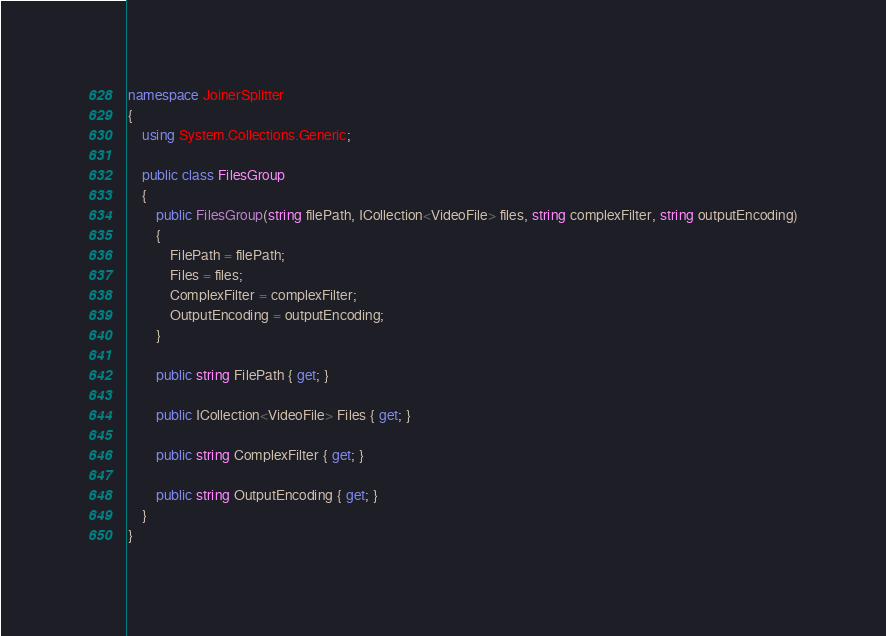<code> <loc_0><loc_0><loc_500><loc_500><_C#_>namespace JoinerSplitter
{
    using System.Collections.Generic;

    public class FilesGroup
    {
        public FilesGroup(string filePath, ICollection<VideoFile> files, string complexFilter, string outputEncoding)
        {
            FilePath = filePath;
            Files = files;
            ComplexFilter = complexFilter;
            OutputEncoding = outputEncoding;
        }

        public string FilePath { get; }

        public ICollection<VideoFile> Files { get; }

        public string ComplexFilter { get; }

        public string OutputEncoding { get; }
    }
}</code> 